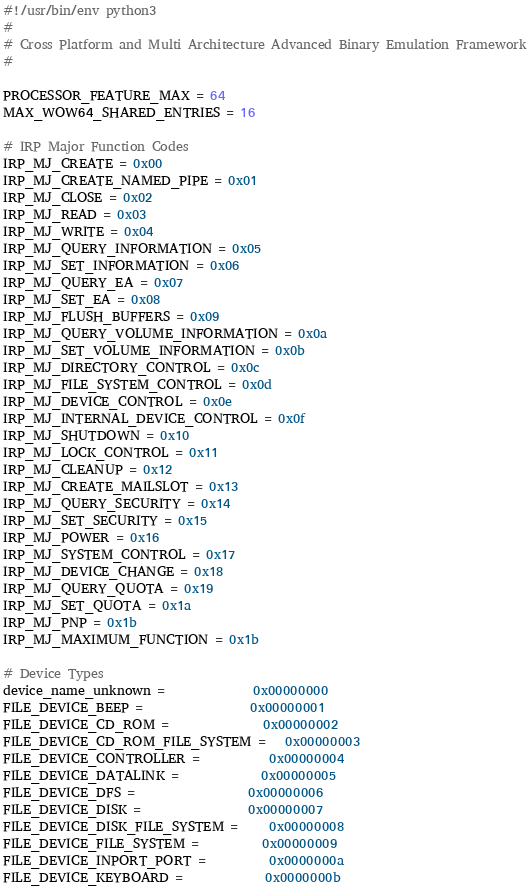Convert code to text. <code><loc_0><loc_0><loc_500><loc_500><_Python_>#!/usr/bin/env python3
#
# Cross Platform and Multi Architecture Advanced Binary Emulation Framework
#

PROCESSOR_FEATURE_MAX = 64
MAX_WOW64_SHARED_ENTRIES = 16

# IRP Major Function Codes
IRP_MJ_CREATE = 0x00
IRP_MJ_CREATE_NAMED_PIPE = 0x01
IRP_MJ_CLOSE = 0x02
IRP_MJ_READ = 0x03
IRP_MJ_WRITE = 0x04
IRP_MJ_QUERY_INFORMATION = 0x05
IRP_MJ_SET_INFORMATION = 0x06
IRP_MJ_QUERY_EA = 0x07
IRP_MJ_SET_EA = 0x08
IRP_MJ_FLUSH_BUFFERS = 0x09
IRP_MJ_QUERY_VOLUME_INFORMATION = 0x0a
IRP_MJ_SET_VOLUME_INFORMATION = 0x0b
IRP_MJ_DIRECTORY_CONTROL = 0x0c
IRP_MJ_FILE_SYSTEM_CONTROL = 0x0d
IRP_MJ_DEVICE_CONTROL = 0x0e
IRP_MJ_INTERNAL_DEVICE_CONTROL = 0x0f
IRP_MJ_SHUTDOWN = 0x10
IRP_MJ_LOCK_CONTROL = 0x11
IRP_MJ_CLEANUP = 0x12
IRP_MJ_CREATE_MAILSLOT = 0x13
IRP_MJ_QUERY_SECURITY = 0x14
IRP_MJ_SET_SECURITY = 0x15
IRP_MJ_POWER = 0x16
IRP_MJ_SYSTEM_CONTROL = 0x17
IRP_MJ_DEVICE_CHANGE = 0x18
IRP_MJ_QUERY_QUOTA = 0x19
IRP_MJ_SET_QUOTA = 0x1a
IRP_MJ_PNP = 0x1b
IRP_MJ_MAXIMUM_FUNCTION = 0x1b

# Device Types
device_name_unknown =              0x00000000
FILE_DEVICE_BEEP =                 0x00000001
FILE_DEVICE_CD_ROM =               0x00000002
FILE_DEVICE_CD_ROM_FILE_SYSTEM =   0x00000003
FILE_DEVICE_CONTROLLER =           0x00000004
FILE_DEVICE_DATALINK =             0x00000005
FILE_DEVICE_DFS =                  0x00000006
FILE_DEVICE_DISK =                 0x00000007
FILE_DEVICE_DISK_FILE_SYSTEM =     0x00000008
FILE_DEVICE_FILE_SYSTEM =          0x00000009
FILE_DEVICE_INPORT_PORT =          0x0000000a
FILE_DEVICE_KEYBOARD =             0x0000000b</code> 